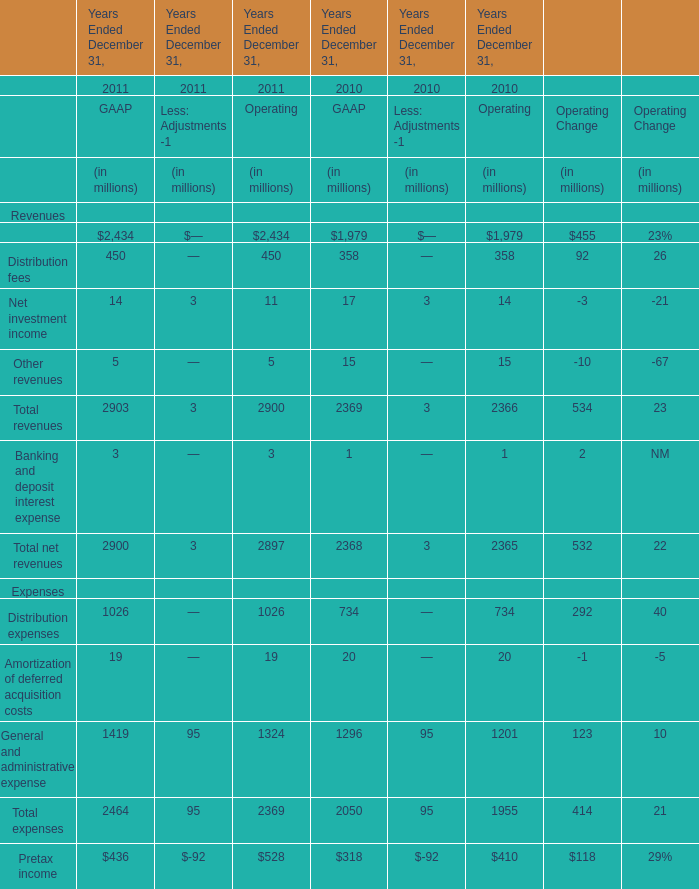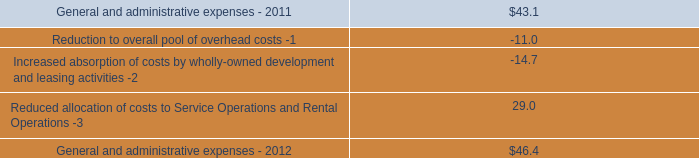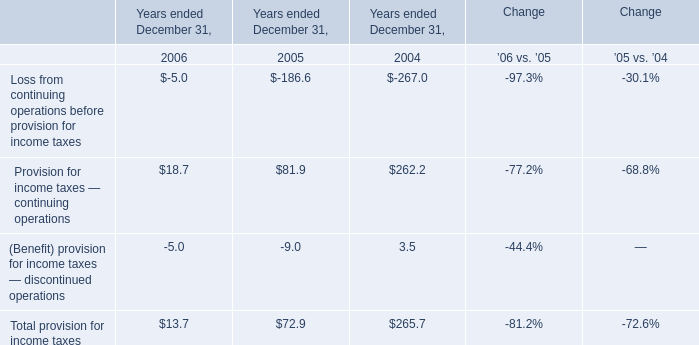What's the total amount of GAAP's Revenues in 2011? (in million) 
Computations: (((2434 + 450) + 14) + 5)
Answer: 2903.0. 